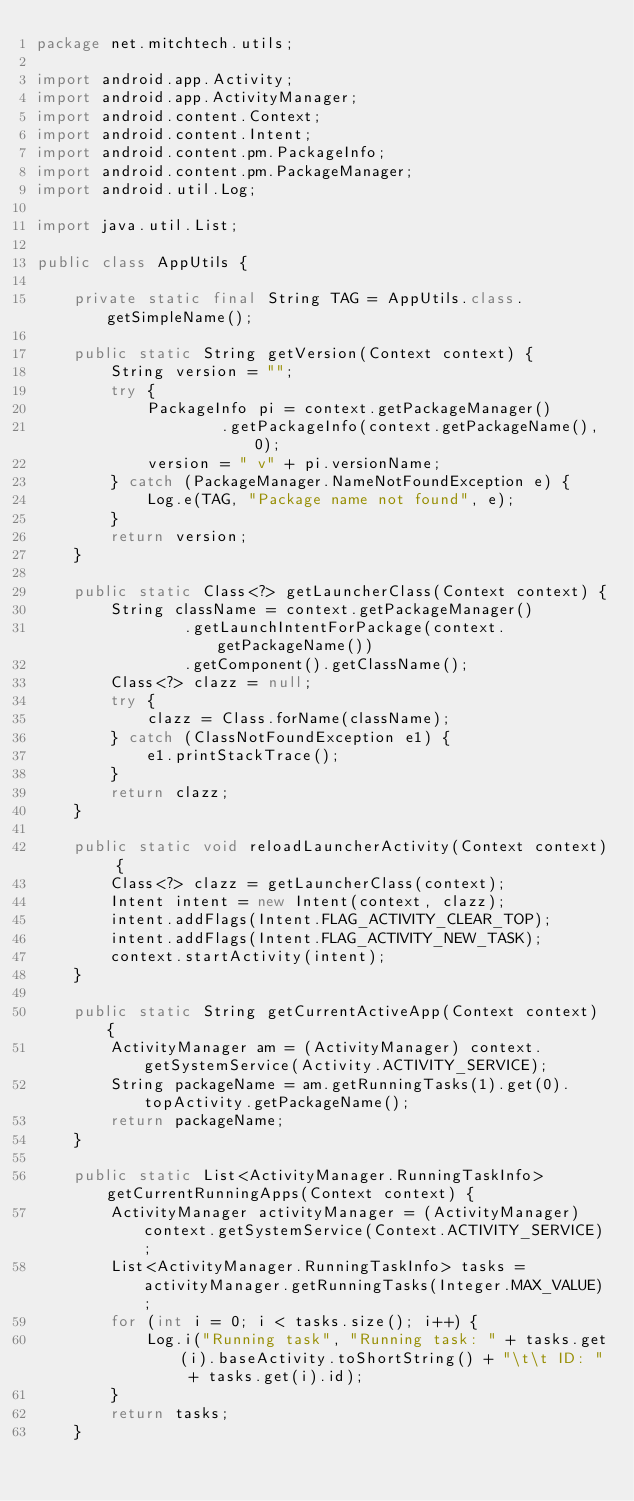Convert code to text. <code><loc_0><loc_0><loc_500><loc_500><_Java_>package net.mitchtech.utils;

import android.app.Activity;
import android.app.ActivityManager;
import android.content.Context;
import android.content.Intent;
import android.content.pm.PackageInfo;
import android.content.pm.PackageManager;
import android.util.Log;

import java.util.List;

public class AppUtils {

    private static final String TAG = AppUtils.class.getSimpleName();

    public static String getVersion(Context context) {
        String version = "";
        try {
            PackageInfo pi = context.getPackageManager()
                    .getPackageInfo(context.getPackageName(), 0);
            version = " v" + pi.versionName;
        } catch (PackageManager.NameNotFoundException e) {
            Log.e(TAG, "Package name not found", e);
        }
        return version;
    }

    public static Class<?> getLauncherClass(Context context) {
        String className = context.getPackageManager()
                .getLaunchIntentForPackage(context.getPackageName())
                .getComponent().getClassName();
        Class<?> clazz = null;
        try {
            clazz = Class.forName(className);
        } catch (ClassNotFoundException e1) {
            e1.printStackTrace();
        }
        return clazz;
    }

    public static void reloadLauncherActivity(Context context) {
        Class<?> clazz = getLauncherClass(context);
        Intent intent = new Intent(context, clazz);
        intent.addFlags(Intent.FLAG_ACTIVITY_CLEAR_TOP);
        intent.addFlags(Intent.FLAG_ACTIVITY_NEW_TASK);
        context.startActivity(intent);
    }

    public static String getCurrentActiveApp(Context context) {
        ActivityManager am = (ActivityManager) context.getSystemService(Activity.ACTIVITY_SERVICE);
        String packageName = am.getRunningTasks(1).get(0).topActivity.getPackageName();
        return packageName;
    }

    public static List<ActivityManager.RunningTaskInfo> getCurrentRunningApps(Context context) {
        ActivityManager activityManager = (ActivityManager) context.getSystemService(Context.ACTIVITY_SERVICE);
        List<ActivityManager.RunningTaskInfo> tasks = activityManager.getRunningTasks(Integer.MAX_VALUE);
        for (int i = 0; i < tasks.size(); i++) {
            Log.i("Running task", "Running task: " + tasks.get(i).baseActivity.toShortString() + "\t\t ID: " + tasks.get(i).id);
        }
        return tasks;
    }
</code> 